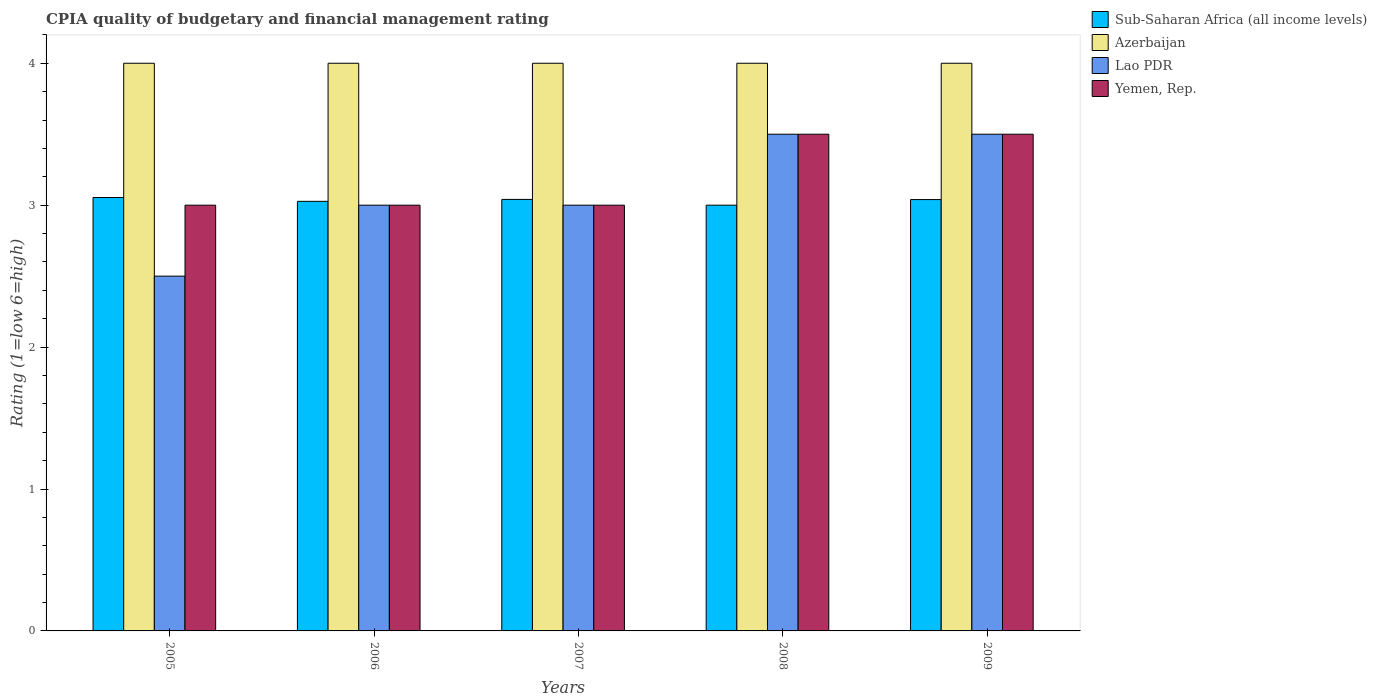How many different coloured bars are there?
Your answer should be very brief. 4. How many groups of bars are there?
Provide a succinct answer. 5. Are the number of bars per tick equal to the number of legend labels?
Offer a very short reply. Yes. Are the number of bars on each tick of the X-axis equal?
Your answer should be very brief. Yes. Across all years, what is the minimum CPIA rating in Yemen, Rep.?
Ensure brevity in your answer.  3. What is the total CPIA rating in Sub-Saharan Africa (all income levels) in the graph?
Your response must be concise. 15.16. What is the difference between the CPIA rating in Azerbaijan in 2007 and that in 2008?
Offer a terse response. 0. What is the difference between the CPIA rating in Sub-Saharan Africa (all income levels) in 2009 and the CPIA rating in Azerbaijan in 2006?
Keep it short and to the point. -0.96. What is the average CPIA rating in Sub-Saharan Africa (all income levels) per year?
Provide a short and direct response. 3.03. In the year 2007, what is the difference between the CPIA rating in Sub-Saharan Africa (all income levels) and CPIA rating in Azerbaijan?
Offer a very short reply. -0.96. What is the ratio of the CPIA rating in Sub-Saharan Africa (all income levels) in 2005 to that in 2007?
Keep it short and to the point. 1. Is the CPIA rating in Azerbaijan in 2006 less than that in 2007?
Your answer should be very brief. No. What is the difference between the highest and the second highest CPIA rating in Sub-Saharan Africa (all income levels)?
Offer a terse response. 0.01. What is the difference between the highest and the lowest CPIA rating in Azerbaijan?
Ensure brevity in your answer.  0. In how many years, is the CPIA rating in Lao PDR greater than the average CPIA rating in Lao PDR taken over all years?
Provide a short and direct response. 2. Is it the case that in every year, the sum of the CPIA rating in Yemen, Rep. and CPIA rating in Sub-Saharan Africa (all income levels) is greater than the sum of CPIA rating in Lao PDR and CPIA rating in Azerbaijan?
Provide a succinct answer. No. What does the 1st bar from the left in 2005 represents?
Give a very brief answer. Sub-Saharan Africa (all income levels). What does the 3rd bar from the right in 2008 represents?
Offer a terse response. Azerbaijan. How many years are there in the graph?
Your answer should be very brief. 5. What is the difference between two consecutive major ticks on the Y-axis?
Offer a terse response. 1. Are the values on the major ticks of Y-axis written in scientific E-notation?
Offer a terse response. No. Does the graph contain grids?
Make the answer very short. No. Where does the legend appear in the graph?
Provide a short and direct response. Top right. What is the title of the graph?
Your response must be concise. CPIA quality of budgetary and financial management rating. What is the label or title of the X-axis?
Offer a terse response. Years. What is the label or title of the Y-axis?
Give a very brief answer. Rating (1=low 6=high). What is the Rating (1=low 6=high) in Sub-Saharan Africa (all income levels) in 2005?
Offer a very short reply. 3.05. What is the Rating (1=low 6=high) of Lao PDR in 2005?
Give a very brief answer. 2.5. What is the Rating (1=low 6=high) in Yemen, Rep. in 2005?
Provide a succinct answer. 3. What is the Rating (1=low 6=high) of Sub-Saharan Africa (all income levels) in 2006?
Your answer should be compact. 3.03. What is the Rating (1=low 6=high) of Azerbaijan in 2006?
Provide a short and direct response. 4. What is the Rating (1=low 6=high) in Lao PDR in 2006?
Ensure brevity in your answer.  3. What is the Rating (1=low 6=high) in Yemen, Rep. in 2006?
Provide a short and direct response. 3. What is the Rating (1=low 6=high) of Sub-Saharan Africa (all income levels) in 2007?
Your answer should be very brief. 3.04. What is the Rating (1=low 6=high) of Lao PDR in 2008?
Provide a succinct answer. 3.5. What is the Rating (1=low 6=high) in Yemen, Rep. in 2008?
Ensure brevity in your answer.  3.5. What is the Rating (1=low 6=high) of Sub-Saharan Africa (all income levels) in 2009?
Your response must be concise. 3.04. What is the Rating (1=low 6=high) of Azerbaijan in 2009?
Give a very brief answer. 4. What is the Rating (1=low 6=high) of Yemen, Rep. in 2009?
Offer a terse response. 3.5. Across all years, what is the maximum Rating (1=low 6=high) of Sub-Saharan Africa (all income levels)?
Your answer should be compact. 3.05. Across all years, what is the maximum Rating (1=low 6=high) of Lao PDR?
Offer a terse response. 3.5. Across all years, what is the minimum Rating (1=low 6=high) of Sub-Saharan Africa (all income levels)?
Ensure brevity in your answer.  3. Across all years, what is the minimum Rating (1=low 6=high) of Lao PDR?
Provide a succinct answer. 2.5. Across all years, what is the minimum Rating (1=low 6=high) in Yemen, Rep.?
Give a very brief answer. 3. What is the total Rating (1=low 6=high) in Sub-Saharan Africa (all income levels) in the graph?
Your answer should be compact. 15.16. What is the total Rating (1=low 6=high) of Yemen, Rep. in the graph?
Give a very brief answer. 16. What is the difference between the Rating (1=low 6=high) in Sub-Saharan Africa (all income levels) in 2005 and that in 2006?
Your response must be concise. 0.03. What is the difference between the Rating (1=low 6=high) of Azerbaijan in 2005 and that in 2006?
Give a very brief answer. 0. What is the difference between the Rating (1=low 6=high) of Sub-Saharan Africa (all income levels) in 2005 and that in 2007?
Your answer should be very brief. 0.01. What is the difference between the Rating (1=low 6=high) in Azerbaijan in 2005 and that in 2007?
Ensure brevity in your answer.  0. What is the difference between the Rating (1=low 6=high) in Sub-Saharan Africa (all income levels) in 2005 and that in 2008?
Your answer should be very brief. 0.05. What is the difference between the Rating (1=low 6=high) of Azerbaijan in 2005 and that in 2008?
Ensure brevity in your answer.  0. What is the difference between the Rating (1=low 6=high) of Sub-Saharan Africa (all income levels) in 2005 and that in 2009?
Offer a terse response. 0.01. What is the difference between the Rating (1=low 6=high) of Lao PDR in 2005 and that in 2009?
Make the answer very short. -1. What is the difference between the Rating (1=low 6=high) in Sub-Saharan Africa (all income levels) in 2006 and that in 2007?
Make the answer very short. -0.01. What is the difference between the Rating (1=low 6=high) of Azerbaijan in 2006 and that in 2007?
Your answer should be compact. 0. What is the difference between the Rating (1=low 6=high) in Sub-Saharan Africa (all income levels) in 2006 and that in 2008?
Make the answer very short. 0.03. What is the difference between the Rating (1=low 6=high) in Lao PDR in 2006 and that in 2008?
Offer a terse response. -0.5. What is the difference between the Rating (1=low 6=high) in Yemen, Rep. in 2006 and that in 2008?
Offer a terse response. -0.5. What is the difference between the Rating (1=low 6=high) in Sub-Saharan Africa (all income levels) in 2006 and that in 2009?
Keep it short and to the point. -0.01. What is the difference between the Rating (1=low 6=high) in Azerbaijan in 2006 and that in 2009?
Give a very brief answer. 0. What is the difference between the Rating (1=low 6=high) in Yemen, Rep. in 2006 and that in 2009?
Keep it short and to the point. -0.5. What is the difference between the Rating (1=low 6=high) in Sub-Saharan Africa (all income levels) in 2007 and that in 2008?
Provide a short and direct response. 0.04. What is the difference between the Rating (1=low 6=high) of Azerbaijan in 2007 and that in 2008?
Your answer should be very brief. 0. What is the difference between the Rating (1=low 6=high) of Yemen, Rep. in 2007 and that in 2008?
Your answer should be compact. -0.5. What is the difference between the Rating (1=low 6=high) of Sub-Saharan Africa (all income levels) in 2007 and that in 2009?
Your answer should be compact. 0. What is the difference between the Rating (1=low 6=high) of Azerbaijan in 2007 and that in 2009?
Provide a short and direct response. 0. What is the difference between the Rating (1=low 6=high) in Sub-Saharan Africa (all income levels) in 2008 and that in 2009?
Offer a terse response. -0.04. What is the difference between the Rating (1=low 6=high) in Lao PDR in 2008 and that in 2009?
Your answer should be compact. 0. What is the difference between the Rating (1=low 6=high) of Sub-Saharan Africa (all income levels) in 2005 and the Rating (1=low 6=high) of Azerbaijan in 2006?
Your answer should be very brief. -0.95. What is the difference between the Rating (1=low 6=high) in Sub-Saharan Africa (all income levels) in 2005 and the Rating (1=low 6=high) in Lao PDR in 2006?
Your answer should be very brief. 0.05. What is the difference between the Rating (1=low 6=high) of Sub-Saharan Africa (all income levels) in 2005 and the Rating (1=low 6=high) of Yemen, Rep. in 2006?
Ensure brevity in your answer.  0.05. What is the difference between the Rating (1=low 6=high) of Azerbaijan in 2005 and the Rating (1=low 6=high) of Yemen, Rep. in 2006?
Provide a short and direct response. 1. What is the difference between the Rating (1=low 6=high) of Lao PDR in 2005 and the Rating (1=low 6=high) of Yemen, Rep. in 2006?
Your answer should be very brief. -0.5. What is the difference between the Rating (1=low 6=high) of Sub-Saharan Africa (all income levels) in 2005 and the Rating (1=low 6=high) of Azerbaijan in 2007?
Provide a succinct answer. -0.95. What is the difference between the Rating (1=low 6=high) in Sub-Saharan Africa (all income levels) in 2005 and the Rating (1=low 6=high) in Lao PDR in 2007?
Your answer should be very brief. 0.05. What is the difference between the Rating (1=low 6=high) of Sub-Saharan Africa (all income levels) in 2005 and the Rating (1=low 6=high) of Yemen, Rep. in 2007?
Give a very brief answer. 0.05. What is the difference between the Rating (1=low 6=high) in Azerbaijan in 2005 and the Rating (1=low 6=high) in Yemen, Rep. in 2007?
Your answer should be compact. 1. What is the difference between the Rating (1=low 6=high) in Lao PDR in 2005 and the Rating (1=low 6=high) in Yemen, Rep. in 2007?
Your answer should be compact. -0.5. What is the difference between the Rating (1=low 6=high) in Sub-Saharan Africa (all income levels) in 2005 and the Rating (1=low 6=high) in Azerbaijan in 2008?
Ensure brevity in your answer.  -0.95. What is the difference between the Rating (1=low 6=high) in Sub-Saharan Africa (all income levels) in 2005 and the Rating (1=low 6=high) in Lao PDR in 2008?
Make the answer very short. -0.45. What is the difference between the Rating (1=low 6=high) of Sub-Saharan Africa (all income levels) in 2005 and the Rating (1=low 6=high) of Yemen, Rep. in 2008?
Offer a terse response. -0.45. What is the difference between the Rating (1=low 6=high) of Azerbaijan in 2005 and the Rating (1=low 6=high) of Lao PDR in 2008?
Provide a short and direct response. 0.5. What is the difference between the Rating (1=low 6=high) in Lao PDR in 2005 and the Rating (1=low 6=high) in Yemen, Rep. in 2008?
Offer a very short reply. -1. What is the difference between the Rating (1=low 6=high) of Sub-Saharan Africa (all income levels) in 2005 and the Rating (1=low 6=high) of Azerbaijan in 2009?
Provide a succinct answer. -0.95. What is the difference between the Rating (1=low 6=high) of Sub-Saharan Africa (all income levels) in 2005 and the Rating (1=low 6=high) of Lao PDR in 2009?
Make the answer very short. -0.45. What is the difference between the Rating (1=low 6=high) in Sub-Saharan Africa (all income levels) in 2005 and the Rating (1=low 6=high) in Yemen, Rep. in 2009?
Keep it short and to the point. -0.45. What is the difference between the Rating (1=low 6=high) of Azerbaijan in 2005 and the Rating (1=low 6=high) of Lao PDR in 2009?
Your response must be concise. 0.5. What is the difference between the Rating (1=low 6=high) in Azerbaijan in 2005 and the Rating (1=low 6=high) in Yemen, Rep. in 2009?
Keep it short and to the point. 0.5. What is the difference between the Rating (1=low 6=high) of Lao PDR in 2005 and the Rating (1=low 6=high) of Yemen, Rep. in 2009?
Your answer should be very brief. -1. What is the difference between the Rating (1=low 6=high) in Sub-Saharan Africa (all income levels) in 2006 and the Rating (1=low 6=high) in Azerbaijan in 2007?
Keep it short and to the point. -0.97. What is the difference between the Rating (1=low 6=high) of Sub-Saharan Africa (all income levels) in 2006 and the Rating (1=low 6=high) of Lao PDR in 2007?
Keep it short and to the point. 0.03. What is the difference between the Rating (1=low 6=high) of Sub-Saharan Africa (all income levels) in 2006 and the Rating (1=low 6=high) of Yemen, Rep. in 2007?
Keep it short and to the point. 0.03. What is the difference between the Rating (1=low 6=high) of Azerbaijan in 2006 and the Rating (1=low 6=high) of Lao PDR in 2007?
Make the answer very short. 1. What is the difference between the Rating (1=low 6=high) in Lao PDR in 2006 and the Rating (1=low 6=high) in Yemen, Rep. in 2007?
Keep it short and to the point. 0. What is the difference between the Rating (1=low 6=high) of Sub-Saharan Africa (all income levels) in 2006 and the Rating (1=low 6=high) of Azerbaijan in 2008?
Make the answer very short. -0.97. What is the difference between the Rating (1=low 6=high) in Sub-Saharan Africa (all income levels) in 2006 and the Rating (1=low 6=high) in Lao PDR in 2008?
Offer a very short reply. -0.47. What is the difference between the Rating (1=low 6=high) of Sub-Saharan Africa (all income levels) in 2006 and the Rating (1=low 6=high) of Yemen, Rep. in 2008?
Provide a short and direct response. -0.47. What is the difference between the Rating (1=low 6=high) in Lao PDR in 2006 and the Rating (1=low 6=high) in Yemen, Rep. in 2008?
Your answer should be compact. -0.5. What is the difference between the Rating (1=low 6=high) of Sub-Saharan Africa (all income levels) in 2006 and the Rating (1=low 6=high) of Azerbaijan in 2009?
Your answer should be compact. -0.97. What is the difference between the Rating (1=low 6=high) in Sub-Saharan Africa (all income levels) in 2006 and the Rating (1=low 6=high) in Lao PDR in 2009?
Give a very brief answer. -0.47. What is the difference between the Rating (1=low 6=high) in Sub-Saharan Africa (all income levels) in 2006 and the Rating (1=low 6=high) in Yemen, Rep. in 2009?
Ensure brevity in your answer.  -0.47. What is the difference between the Rating (1=low 6=high) of Azerbaijan in 2006 and the Rating (1=low 6=high) of Lao PDR in 2009?
Your answer should be very brief. 0.5. What is the difference between the Rating (1=low 6=high) in Azerbaijan in 2006 and the Rating (1=low 6=high) in Yemen, Rep. in 2009?
Your answer should be very brief. 0.5. What is the difference between the Rating (1=low 6=high) of Sub-Saharan Africa (all income levels) in 2007 and the Rating (1=low 6=high) of Azerbaijan in 2008?
Offer a very short reply. -0.96. What is the difference between the Rating (1=low 6=high) of Sub-Saharan Africa (all income levels) in 2007 and the Rating (1=low 6=high) of Lao PDR in 2008?
Provide a short and direct response. -0.46. What is the difference between the Rating (1=low 6=high) of Sub-Saharan Africa (all income levels) in 2007 and the Rating (1=low 6=high) of Yemen, Rep. in 2008?
Your answer should be very brief. -0.46. What is the difference between the Rating (1=low 6=high) of Azerbaijan in 2007 and the Rating (1=low 6=high) of Lao PDR in 2008?
Offer a terse response. 0.5. What is the difference between the Rating (1=low 6=high) in Lao PDR in 2007 and the Rating (1=low 6=high) in Yemen, Rep. in 2008?
Offer a terse response. -0.5. What is the difference between the Rating (1=low 6=high) of Sub-Saharan Africa (all income levels) in 2007 and the Rating (1=low 6=high) of Azerbaijan in 2009?
Offer a terse response. -0.96. What is the difference between the Rating (1=low 6=high) in Sub-Saharan Africa (all income levels) in 2007 and the Rating (1=low 6=high) in Lao PDR in 2009?
Offer a terse response. -0.46. What is the difference between the Rating (1=low 6=high) of Sub-Saharan Africa (all income levels) in 2007 and the Rating (1=low 6=high) of Yemen, Rep. in 2009?
Provide a short and direct response. -0.46. What is the difference between the Rating (1=low 6=high) of Sub-Saharan Africa (all income levels) in 2008 and the Rating (1=low 6=high) of Azerbaijan in 2009?
Offer a very short reply. -1. What is the difference between the Rating (1=low 6=high) in Azerbaijan in 2008 and the Rating (1=low 6=high) in Lao PDR in 2009?
Offer a very short reply. 0.5. What is the difference between the Rating (1=low 6=high) in Azerbaijan in 2008 and the Rating (1=low 6=high) in Yemen, Rep. in 2009?
Give a very brief answer. 0.5. What is the difference between the Rating (1=low 6=high) of Lao PDR in 2008 and the Rating (1=low 6=high) of Yemen, Rep. in 2009?
Make the answer very short. 0. What is the average Rating (1=low 6=high) in Sub-Saharan Africa (all income levels) per year?
Offer a terse response. 3.03. What is the average Rating (1=low 6=high) of Lao PDR per year?
Provide a short and direct response. 3.1. In the year 2005, what is the difference between the Rating (1=low 6=high) in Sub-Saharan Africa (all income levels) and Rating (1=low 6=high) in Azerbaijan?
Your answer should be very brief. -0.95. In the year 2005, what is the difference between the Rating (1=low 6=high) in Sub-Saharan Africa (all income levels) and Rating (1=low 6=high) in Lao PDR?
Offer a terse response. 0.55. In the year 2005, what is the difference between the Rating (1=low 6=high) in Sub-Saharan Africa (all income levels) and Rating (1=low 6=high) in Yemen, Rep.?
Ensure brevity in your answer.  0.05. In the year 2006, what is the difference between the Rating (1=low 6=high) in Sub-Saharan Africa (all income levels) and Rating (1=low 6=high) in Azerbaijan?
Offer a terse response. -0.97. In the year 2006, what is the difference between the Rating (1=low 6=high) of Sub-Saharan Africa (all income levels) and Rating (1=low 6=high) of Lao PDR?
Make the answer very short. 0.03. In the year 2006, what is the difference between the Rating (1=low 6=high) of Sub-Saharan Africa (all income levels) and Rating (1=low 6=high) of Yemen, Rep.?
Provide a succinct answer. 0.03. In the year 2006, what is the difference between the Rating (1=low 6=high) in Azerbaijan and Rating (1=low 6=high) in Lao PDR?
Offer a terse response. 1. In the year 2006, what is the difference between the Rating (1=low 6=high) of Azerbaijan and Rating (1=low 6=high) of Yemen, Rep.?
Provide a succinct answer. 1. In the year 2007, what is the difference between the Rating (1=low 6=high) in Sub-Saharan Africa (all income levels) and Rating (1=low 6=high) in Azerbaijan?
Your answer should be compact. -0.96. In the year 2007, what is the difference between the Rating (1=low 6=high) of Sub-Saharan Africa (all income levels) and Rating (1=low 6=high) of Lao PDR?
Your response must be concise. 0.04. In the year 2007, what is the difference between the Rating (1=low 6=high) in Sub-Saharan Africa (all income levels) and Rating (1=low 6=high) in Yemen, Rep.?
Offer a very short reply. 0.04. In the year 2007, what is the difference between the Rating (1=low 6=high) in Azerbaijan and Rating (1=low 6=high) in Yemen, Rep.?
Keep it short and to the point. 1. In the year 2007, what is the difference between the Rating (1=low 6=high) of Lao PDR and Rating (1=low 6=high) of Yemen, Rep.?
Provide a succinct answer. 0. In the year 2008, what is the difference between the Rating (1=low 6=high) of Sub-Saharan Africa (all income levels) and Rating (1=low 6=high) of Azerbaijan?
Provide a succinct answer. -1. In the year 2008, what is the difference between the Rating (1=low 6=high) in Sub-Saharan Africa (all income levels) and Rating (1=low 6=high) in Lao PDR?
Offer a very short reply. -0.5. In the year 2008, what is the difference between the Rating (1=low 6=high) of Sub-Saharan Africa (all income levels) and Rating (1=low 6=high) of Yemen, Rep.?
Keep it short and to the point. -0.5. In the year 2008, what is the difference between the Rating (1=low 6=high) in Azerbaijan and Rating (1=low 6=high) in Yemen, Rep.?
Provide a short and direct response. 0.5. In the year 2009, what is the difference between the Rating (1=low 6=high) in Sub-Saharan Africa (all income levels) and Rating (1=low 6=high) in Azerbaijan?
Provide a short and direct response. -0.96. In the year 2009, what is the difference between the Rating (1=low 6=high) of Sub-Saharan Africa (all income levels) and Rating (1=low 6=high) of Lao PDR?
Offer a terse response. -0.46. In the year 2009, what is the difference between the Rating (1=low 6=high) of Sub-Saharan Africa (all income levels) and Rating (1=low 6=high) of Yemen, Rep.?
Your answer should be very brief. -0.46. In the year 2009, what is the difference between the Rating (1=low 6=high) in Lao PDR and Rating (1=low 6=high) in Yemen, Rep.?
Provide a succinct answer. 0. What is the ratio of the Rating (1=low 6=high) in Sub-Saharan Africa (all income levels) in 2005 to that in 2006?
Make the answer very short. 1.01. What is the ratio of the Rating (1=low 6=high) in Azerbaijan in 2005 to that in 2006?
Ensure brevity in your answer.  1. What is the ratio of the Rating (1=low 6=high) of Yemen, Rep. in 2005 to that in 2006?
Offer a terse response. 1. What is the ratio of the Rating (1=low 6=high) of Sub-Saharan Africa (all income levels) in 2005 to that in 2007?
Provide a succinct answer. 1. What is the ratio of the Rating (1=low 6=high) in Yemen, Rep. in 2005 to that in 2007?
Make the answer very short. 1. What is the ratio of the Rating (1=low 6=high) in Sub-Saharan Africa (all income levels) in 2005 to that in 2008?
Provide a succinct answer. 1.02. What is the ratio of the Rating (1=low 6=high) of Azerbaijan in 2005 to that in 2008?
Ensure brevity in your answer.  1. What is the ratio of the Rating (1=low 6=high) in Yemen, Rep. in 2005 to that in 2008?
Provide a succinct answer. 0.86. What is the ratio of the Rating (1=low 6=high) in Azerbaijan in 2006 to that in 2007?
Ensure brevity in your answer.  1. What is the ratio of the Rating (1=low 6=high) of Lao PDR in 2006 to that in 2007?
Give a very brief answer. 1. What is the ratio of the Rating (1=low 6=high) in Yemen, Rep. in 2006 to that in 2007?
Your answer should be compact. 1. What is the ratio of the Rating (1=low 6=high) in Lao PDR in 2006 to that in 2008?
Offer a very short reply. 0.86. What is the ratio of the Rating (1=low 6=high) in Yemen, Rep. in 2006 to that in 2008?
Keep it short and to the point. 0.86. What is the ratio of the Rating (1=low 6=high) in Sub-Saharan Africa (all income levels) in 2006 to that in 2009?
Your response must be concise. 1. What is the ratio of the Rating (1=low 6=high) of Azerbaijan in 2006 to that in 2009?
Provide a short and direct response. 1. What is the ratio of the Rating (1=low 6=high) in Yemen, Rep. in 2006 to that in 2009?
Provide a short and direct response. 0.86. What is the ratio of the Rating (1=low 6=high) in Sub-Saharan Africa (all income levels) in 2007 to that in 2008?
Your response must be concise. 1.01. What is the ratio of the Rating (1=low 6=high) in Sub-Saharan Africa (all income levels) in 2007 to that in 2009?
Provide a short and direct response. 1. What is the ratio of the Rating (1=low 6=high) of Azerbaijan in 2007 to that in 2009?
Ensure brevity in your answer.  1. What is the ratio of the Rating (1=low 6=high) in Yemen, Rep. in 2007 to that in 2009?
Provide a short and direct response. 0.86. What is the ratio of the Rating (1=low 6=high) in Sub-Saharan Africa (all income levels) in 2008 to that in 2009?
Your answer should be compact. 0.99. What is the ratio of the Rating (1=low 6=high) of Lao PDR in 2008 to that in 2009?
Offer a terse response. 1. What is the ratio of the Rating (1=low 6=high) in Yemen, Rep. in 2008 to that in 2009?
Provide a succinct answer. 1. What is the difference between the highest and the second highest Rating (1=low 6=high) in Sub-Saharan Africa (all income levels)?
Ensure brevity in your answer.  0.01. What is the difference between the highest and the second highest Rating (1=low 6=high) in Azerbaijan?
Provide a short and direct response. 0. What is the difference between the highest and the second highest Rating (1=low 6=high) of Yemen, Rep.?
Provide a succinct answer. 0. What is the difference between the highest and the lowest Rating (1=low 6=high) of Sub-Saharan Africa (all income levels)?
Give a very brief answer. 0.05. What is the difference between the highest and the lowest Rating (1=low 6=high) of Azerbaijan?
Offer a very short reply. 0. What is the difference between the highest and the lowest Rating (1=low 6=high) of Yemen, Rep.?
Offer a very short reply. 0.5. 